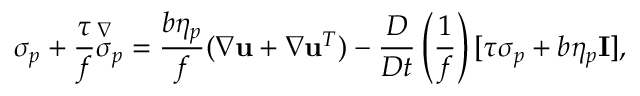Convert formula to latex. <formula><loc_0><loc_0><loc_500><loc_500>\sigma _ { p } + \frac { \tau } { f } \overset { \nabla } { \sigma } _ { p } = \frac { b \eta _ { p } } { f } ( \nabla u + \nabla u ^ { T } ) - \frac { D } { D t } \left ( \frac { 1 } { f } \right ) [ \tau \sigma _ { p } + b \eta _ { p } I ] ,</formula> 